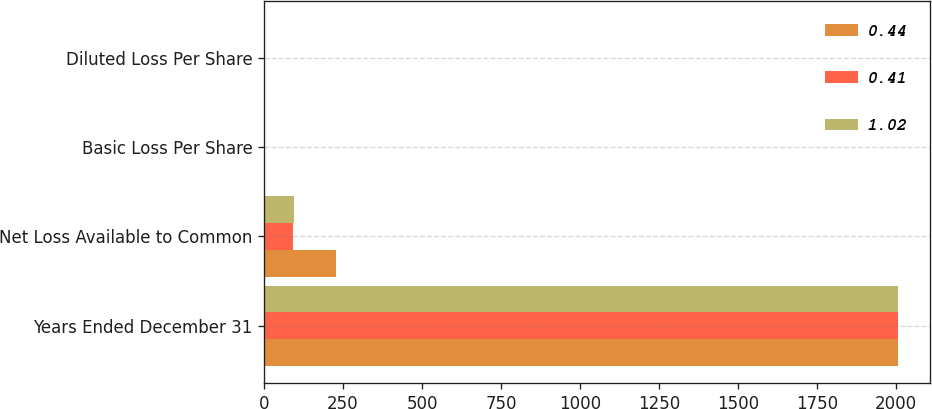Convert chart. <chart><loc_0><loc_0><loc_500><loc_500><stacked_bar_chart><ecel><fcel>Years Ended December 31<fcel>Net Loss Available to Common<fcel>Basic Loss Per Share<fcel>Diluted Loss Per Share<nl><fcel>0.44<fcel>2007<fcel>227<fcel>1.02<fcel>1.02<nl><fcel>0.41<fcel>2006<fcel>90<fcel>0.41<fcel>0.41<nl><fcel>1.02<fcel>2005<fcel>94<fcel>0.44<fcel>0.44<nl></chart> 